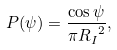Convert formula to latex. <formula><loc_0><loc_0><loc_500><loc_500>P ( \psi ) = \frac { \cos \psi } { \pi { R _ { I } } ^ { 2 } } ,</formula> 